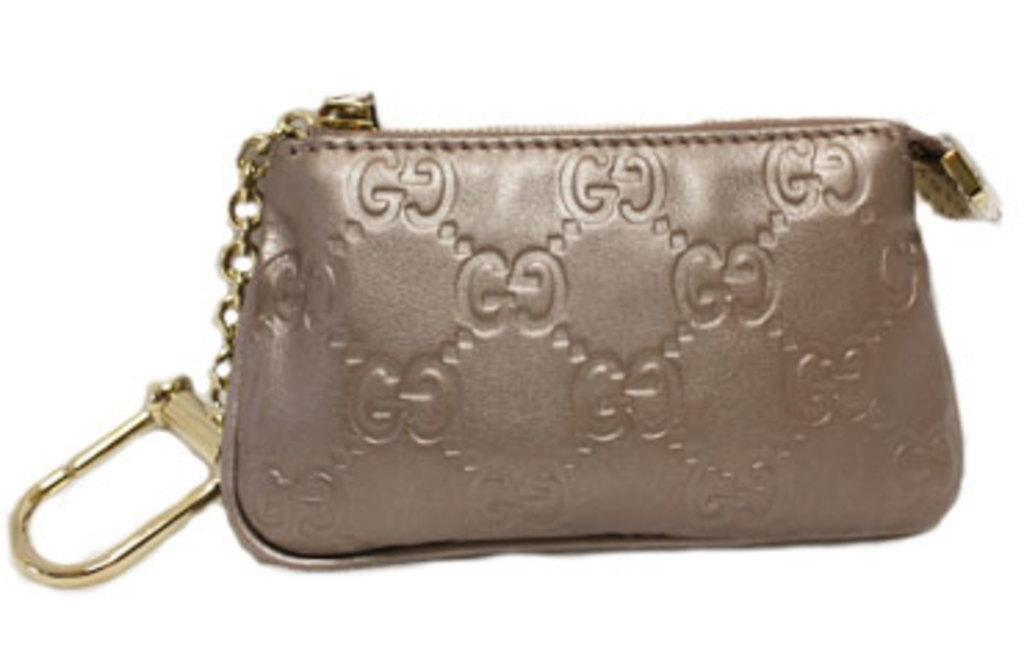What object can be seen in the image? There is a bag in the image. What type of aunt is present in the image? There is no aunt present in the image; only a bag is visible. What type of transport is used to carry the bag in the image? The image does not show any transport being used to carry the bag, as it only shows the bag itself. What type of apparatus is used to open the bag in the image? The image does not show any apparatus being used to open the bag, as it only shows the bag. 